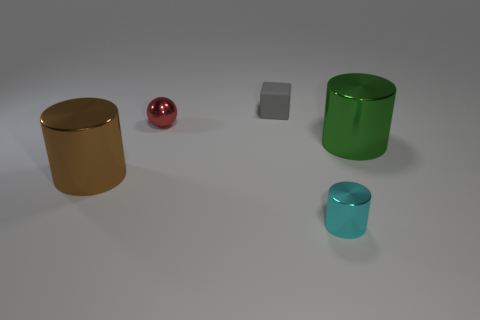Add 1 tiny blue matte balls. How many objects exist? 6 Subtract all cubes. How many objects are left? 4 Subtract all big brown shiny things. Subtract all small spheres. How many objects are left? 3 Add 4 gray rubber cubes. How many gray rubber cubes are left? 5 Add 3 large green shiny cylinders. How many large green shiny cylinders exist? 4 Subtract 1 gray blocks. How many objects are left? 4 